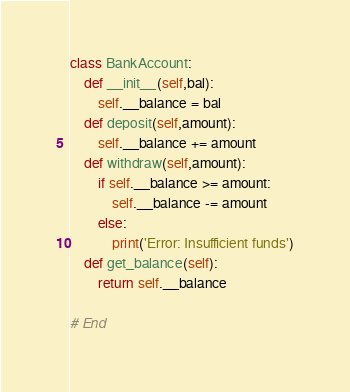Convert code to text. <code><loc_0><loc_0><loc_500><loc_500><_Python_>class BankAccount:
    def __init__(self,bal):
        self.__balance = bal
    def deposit(self,amount):
        self.__balance += amount
    def withdraw(self,amount):
        if self.__balance >= amount:
            self.__balance -= amount
        else:
            print('Error: Insufficient funds')
    def get_balance(self):
        return self.__balance

# End
</code> 